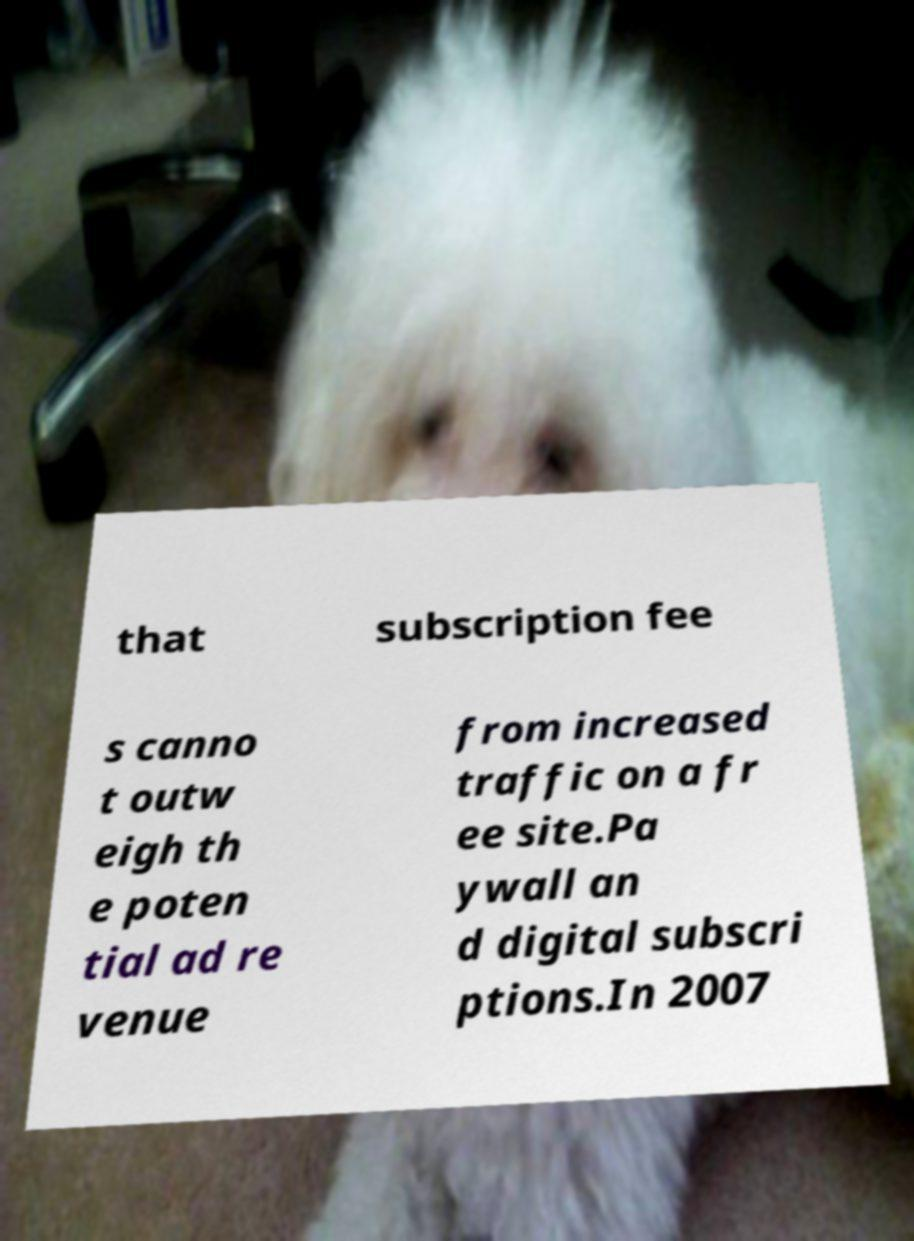For documentation purposes, I need the text within this image transcribed. Could you provide that? that subscription fee s canno t outw eigh th e poten tial ad re venue from increased traffic on a fr ee site.Pa ywall an d digital subscri ptions.In 2007 